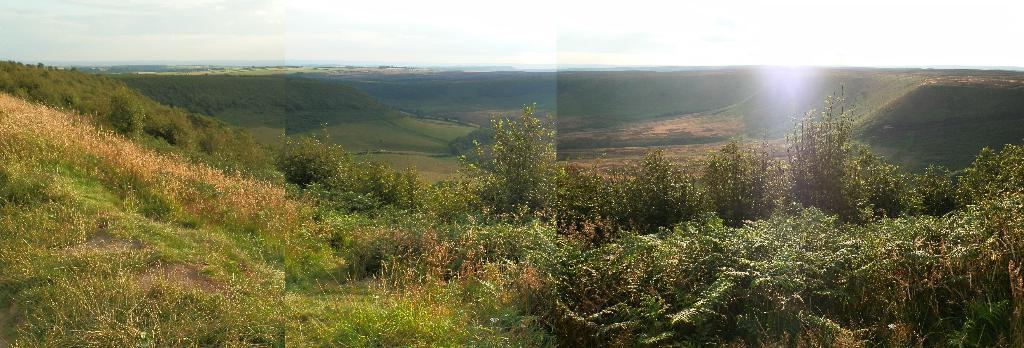How would you summarize this image in a sentence or two? In this image I can see few trees in green color. I can see the green grass and dry grass. The sky is in white color. 